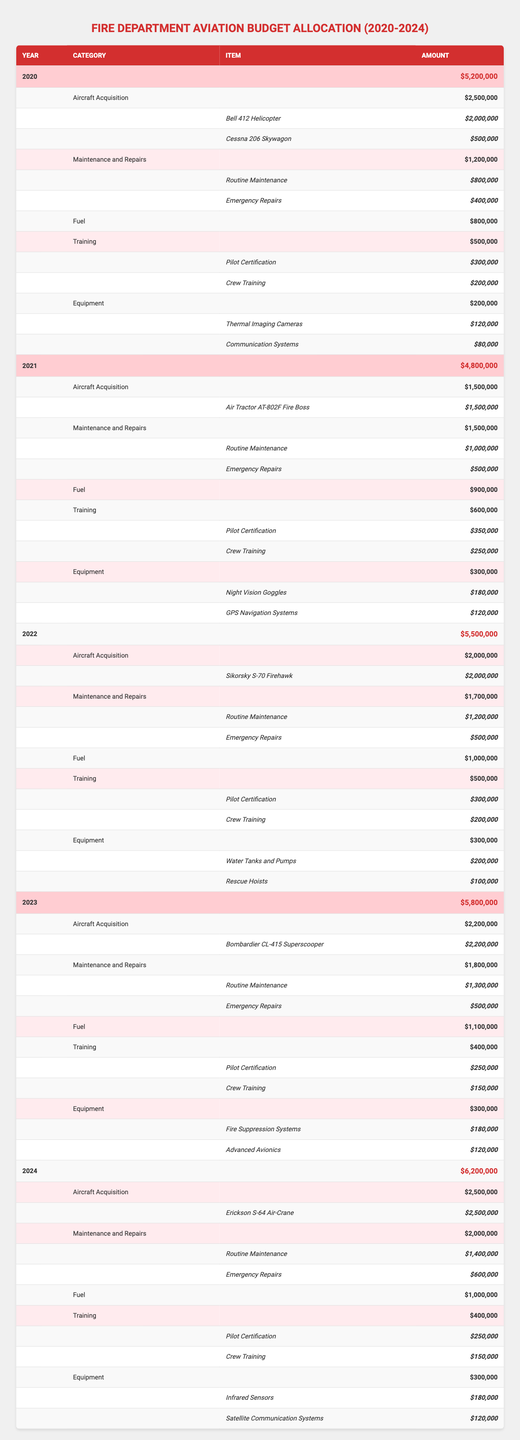What is the total budget allocated for aviation resources in 2022? The total budget for 2022 is provided in the table, which shows $5,500,000 as the total budget for that year.
Answer: $5,500,000 How much was allocated for Aircraft Acquisition in 2023? The table lists the Aircraft Acquisition budget for 2023, which is $2,200,000.
Answer: $2,200,000 What was the average amount allocated for Fuel over the five years? The amounts allocated for Fuel from 2020 to 2024 are $800,000, $900,000, $1,000,000, $1,100,000, and $1,000,000. Adding these gives $800,000 + $900,000 + $1,000,000 + $1,100,000 + $1,000,000 = $4,800,000. Dividing by 5, the average is $4,800,000 / 5 = $960,000.
Answer: $960,000 Did the budget for Maintenance and Repairs increase from 2020 to 2024? In 2020, the budget for Maintenance and Repairs was $1,200,000, and in 2024 it was $2,000,000. Since $2,000,000 is greater than $1,200,000, it confirms that there was an increase.
Answer: Yes What is the total budget for Training across all years? The annual budgets for Training are $500,000 (2020) + $600,000 (2021) + $500,000 (2022) + $400,000 (2023) + $400,000 (2024). Totaling these gives $500,000 + $600,000 + $500,000 + $400,000 + $400,000 = $2,400,000.
Answer: $2,400,000 What was the cost of the most expensive item in the Aircraft Acquisition category in 2021? The only item listed in the Aircraft Acquisition category for 2021 is the Air Tractor AT-802F Fire Boss, which costs $1,500,000. Since it is the only item, it is also the most expensive.
Answer: $1,500,000 How much was spent on Emergency Repairs in 2024? The table specifies that for Maintenance and Repairs in 2024, the amount listed for Emergency Repairs is $600,000.
Answer: $600,000 In which year was the total budget the highest, and what was that amount? The table shows that in 2024, the total budget was $6,200,000, which is higher than the budgets for other years (2020: $5,200,000; 2021: $4,800,000; 2022: $5,500,000; 2023: $5,800,000).
Answer: 2024, $6,200,000 What was the total amount allocated for Equipment in 2022 and 2023 combined? In 2022, the Equipment budget was $300,000, and in 2023 it was also $300,000. Adding these two amounts gives $300,000 + $300,000 = $600,000.
Answer: $600,000 Is the cost of the Bell 412 Helicopter greater than the cost of the Cessna 206 Skywagon? The Bell 412 Helicopter costs $2,000,000, while the Cessna 206 Skywagon costs $500,000. Since $2,000,000 is indeed greater than $500,000, the answer is yes.
Answer: Yes 